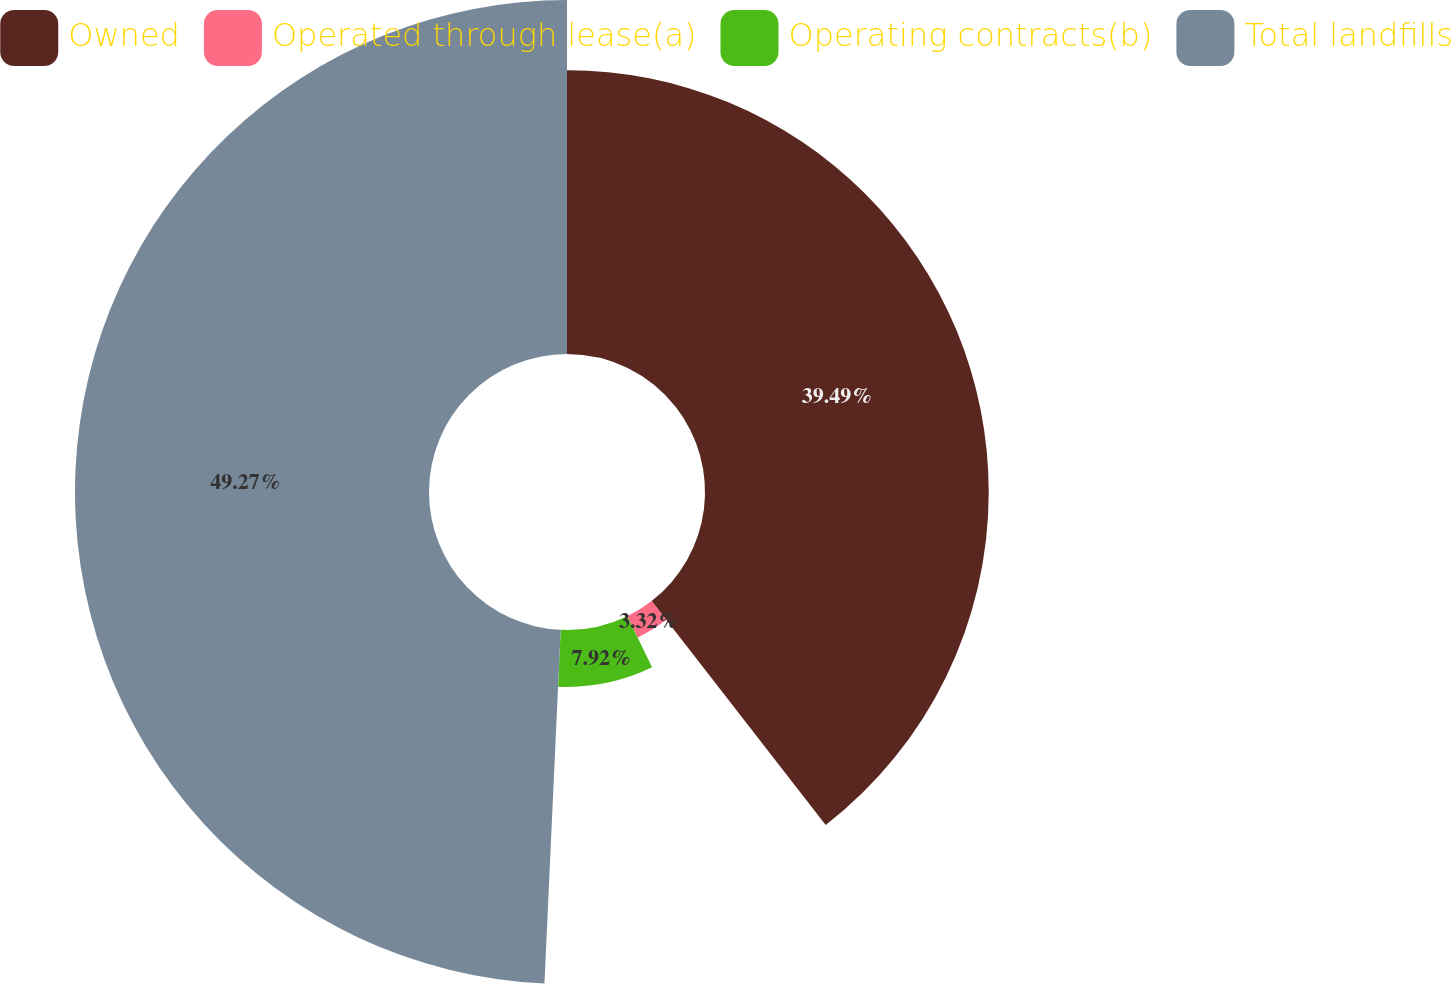Convert chart to OTSL. <chart><loc_0><loc_0><loc_500><loc_500><pie_chart><fcel>Owned<fcel>Operated through lease(a)<fcel>Operating contracts(b)<fcel>Total landfills<nl><fcel>39.49%<fcel>3.32%<fcel>7.92%<fcel>49.27%<nl></chart> 